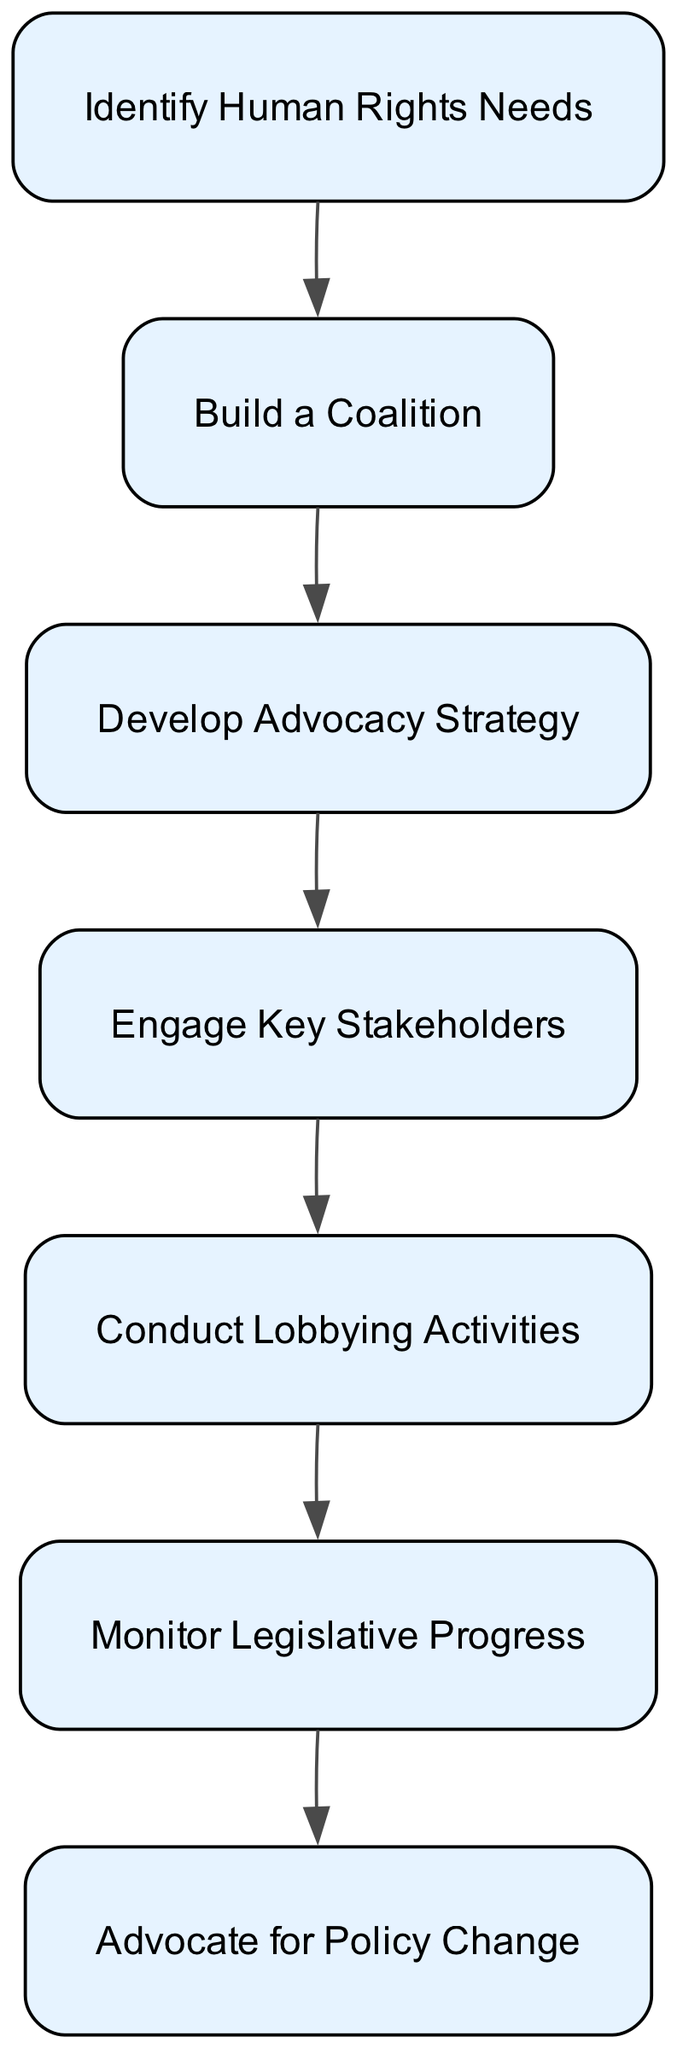What is the first step in the process? The first step is to identify the pressing human rights needs of the community, which is represented at the top of the flow chart.
Answer: Identify Human Rights Needs How many nodes are in the diagram? The diagram consists of seven distinct steps (nodes) outlining the advocacy process from identifying needs to advocating for change.
Answer: Seven What step comes after engaging key stakeholders? The step that follows engaging key stakeholders is conducting lobbying activities, showing the sequential nature of the advocacy process.
Answer: Conduct Lobbying Activities What is the last step in the process? The last step in the diagram is advocating for policy change, indicating it is the culmination of the previous efforts made in the advocacy process.
Answer: Advocate for Policy Change Which step involves forming alliances? Building a coalition is the step in which alliances with other groups are formed to strengthen the advocacy efforts.
Answer: Build a Coalition How many edges are displayed in the diagram? There are six directed edges that represent the flows from one step to the next in the process outlined in the diagram.
Answer: Six What are the key stakeholders engaging in? The key stakeholders are engaged in garnering support, highlighting the importance of collaboration and influence in the legislative process.
Answer: Garner support Why is monitoring legislative progress crucial? Monitoring legislative progress allows advocates to track the success of their efforts and adjust strategies as needed based on legislative developments.
Answer: Track success What is the relationship between identifying human rights needs and developing advocacy strategy? Identifying human rights needs informs the advocacy strategy, as understanding the issues helps to create a targeted and effective plan for engagement.
Answer: Informs strategy 